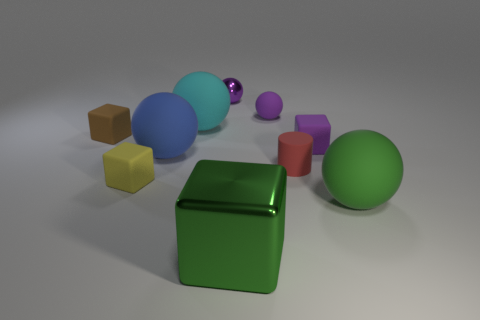Subtract all yellow blocks. How many blocks are left? 3 Subtract 2 spheres. How many spheres are left? 3 Subtract all blue spheres. How many spheres are left? 4 Subtract all gray cubes. Subtract all red balls. How many cubes are left? 4 Subtract all blocks. How many objects are left? 6 Add 5 purple matte things. How many purple matte things exist? 7 Subtract 1 red cylinders. How many objects are left? 9 Subtract all large red shiny cylinders. Subtract all tiny brown objects. How many objects are left? 9 Add 5 tiny matte cubes. How many tiny matte cubes are left? 8 